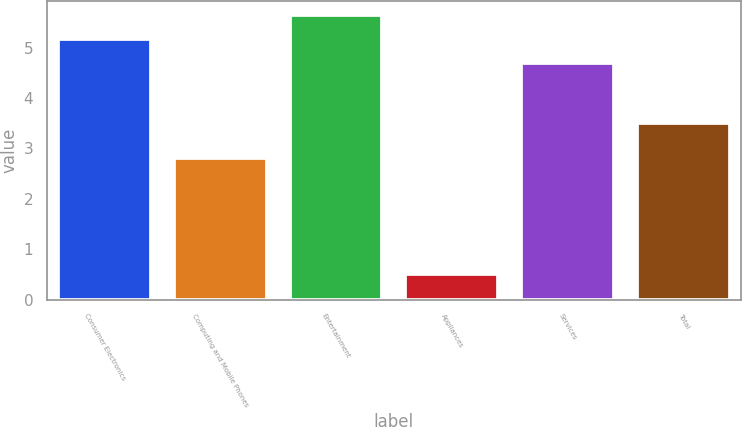<chart> <loc_0><loc_0><loc_500><loc_500><bar_chart><fcel>Consumer Electronics<fcel>Computing and Mobile Phones<fcel>Entertainment<fcel>Appliances<fcel>Services<fcel>Total<nl><fcel>5.17<fcel>2.8<fcel>5.64<fcel>0.5<fcel>4.7<fcel>3.5<nl></chart> 